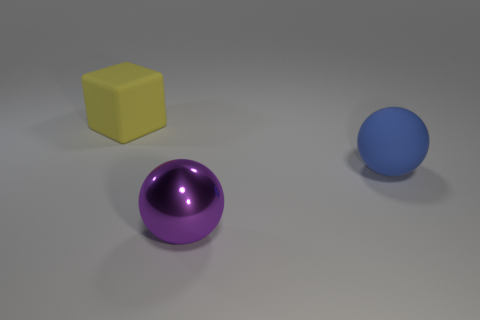Add 3 big metallic things. How many objects exist? 6 Subtract all blocks. How many objects are left? 2 Add 2 big yellow blocks. How many big yellow blocks are left? 3 Add 3 tiny brown rubber cylinders. How many tiny brown rubber cylinders exist? 3 Subtract 0 brown blocks. How many objects are left? 3 Subtract all large gray rubber spheres. Subtract all blue rubber spheres. How many objects are left? 2 